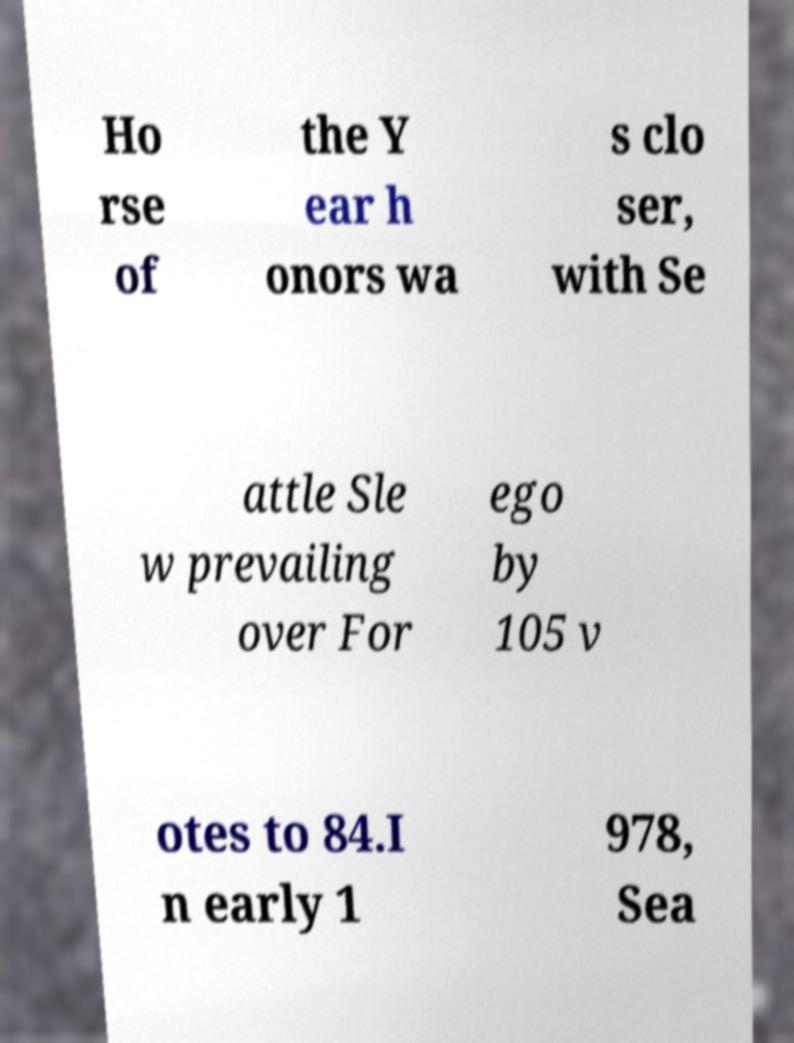Please identify and transcribe the text found in this image. Ho rse of the Y ear h onors wa s clo ser, with Se attle Sle w prevailing over For ego by 105 v otes to 84.I n early 1 978, Sea 